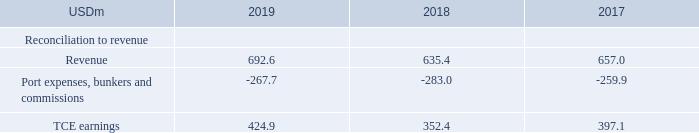ALTERNATIVE PERFORMANCE MEASURES
Time Charter Equivalent (TCE) earnings:
TORM defines TCE earnings, a performance measure, as revenue after port expenses, bunkers and commissions incl. freight and bunker derivatives. The Company reports TCE earnings because we believe it provides additional meaningful information to investors in relation to revenue, the most directly comparable IFRS measure. TCE earnings is a standard shipping industry performance measure used primarily to compare period-to-period changes in a shipping company’s performance irrespective of changes in the mix of charter types (i.e. spot charters, time charters and bareboat charters) under which the vessels may be employed between the periods. Below is presented a reconciliation from Revenue to TCE earnings:
How is TCE earnings defined? Torm defines tce earnings, a performance measure, as revenue after port expenses, bunkers and commissions incl. freight and bunker derivatives. How is TCE earnings used as a standard shipping industry performance measure? Tce earnings is a standard shipping industry performance measure used primarily to compare period-to-period changes in a shipping company’s performance irrespective of changes in the mix of charter types (i.e. spot charters, time charters and bareboat charters) under which the vessels may be employed between the periods. What are the components under Reconciliation to revenue when calculating TCE earnings? Revenue, port expenses, bunkers and commissions. In which year was Revenue the largest? 692.6>657.0>635.4
Answer: 2019. What was the change in TCE earnings in 2019 from 2018?
Answer scale should be: million. 424.9-352.4
Answer: 72.5. What was the percentage change in TCE earnings in 2019 from 2018?
Answer scale should be: percent. (424.9-352.4)/352.4
Answer: 20.57. 